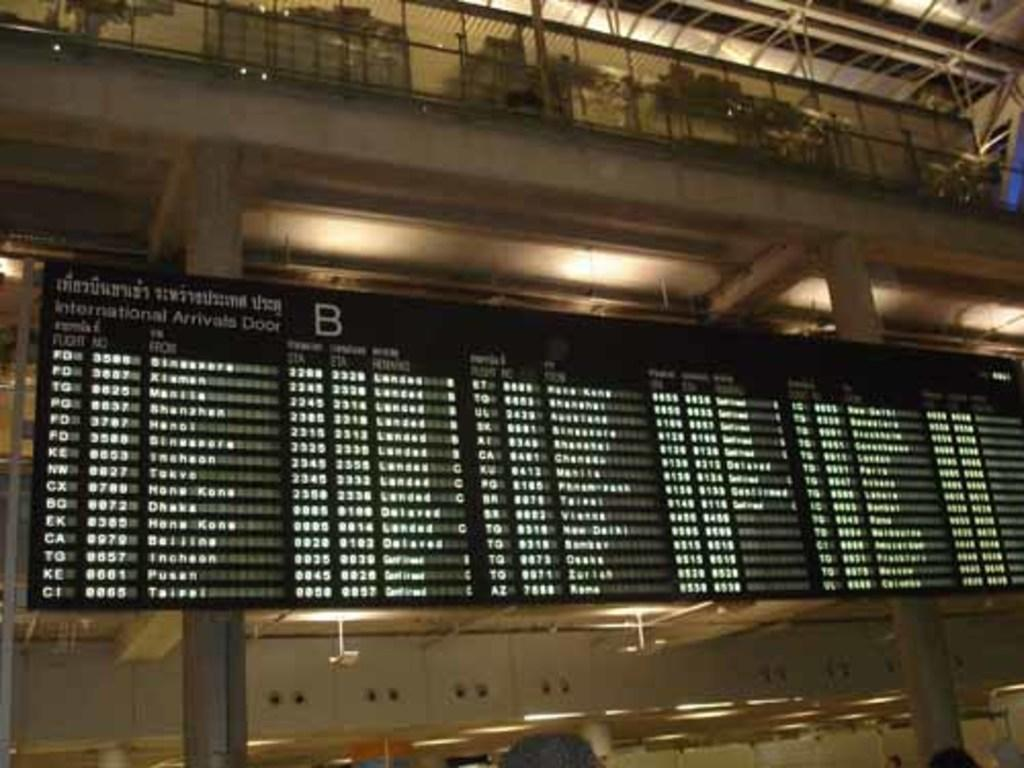What type of digital board is visible in the image? There is a black color digital board in the image. What can be seen in the background of the image? There is a building in the background of the image. What other object is present in the image? There is a pole in the image. How many legs can be seen on the digital board in the image? There are no legs visible on the digital board in the image, as it is a flat, non-living object. 